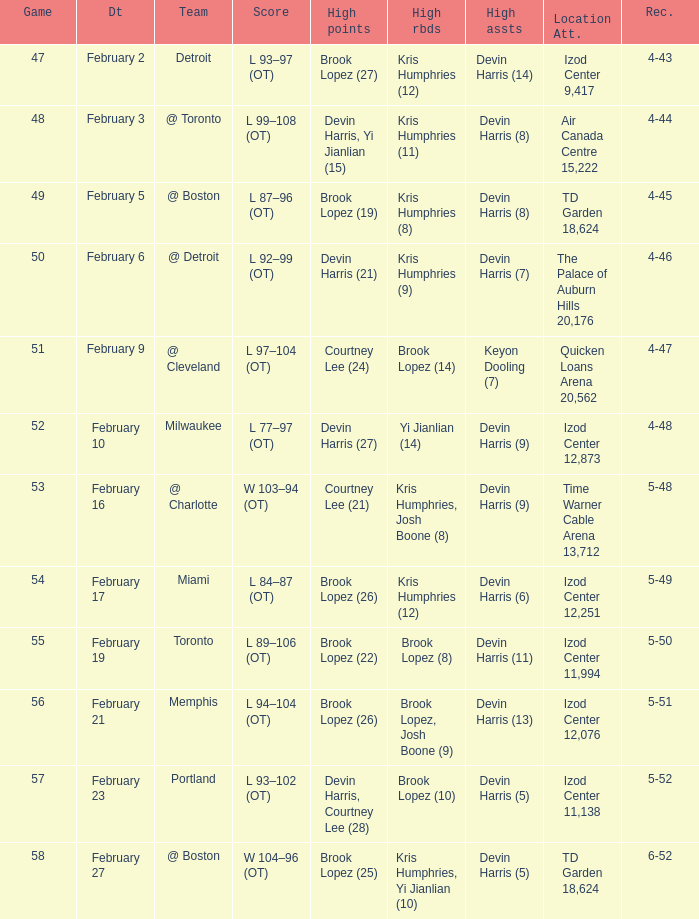Who did the high assists in the game played on February 9? Keyon Dooling (7). 